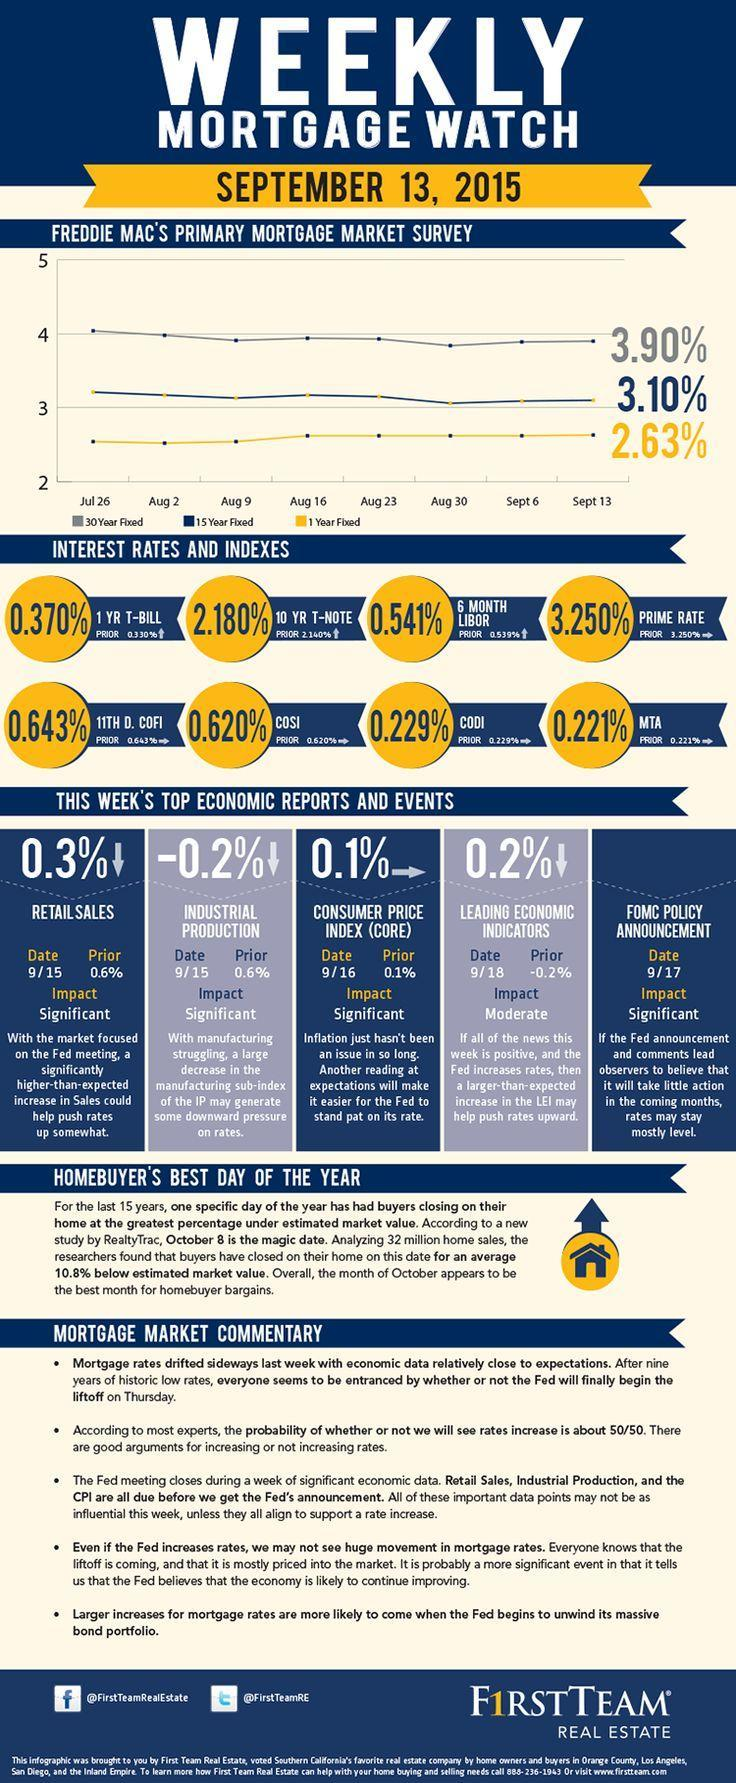What went down by 0.3% on 15th September?
Answer the question with a short phrase. retail sales what stayed at the same value of 0.1% on 16th September? Consumer price index 